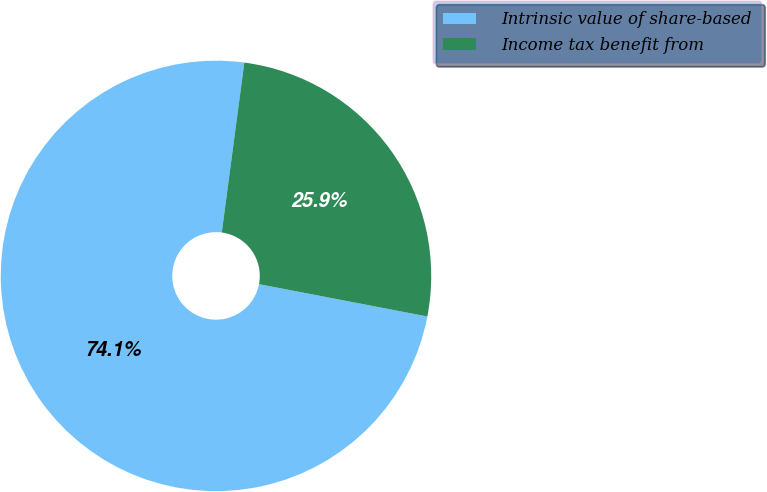<chart> <loc_0><loc_0><loc_500><loc_500><pie_chart><fcel>Intrinsic value of share-based<fcel>Income tax benefit from<nl><fcel>74.08%<fcel>25.92%<nl></chart> 